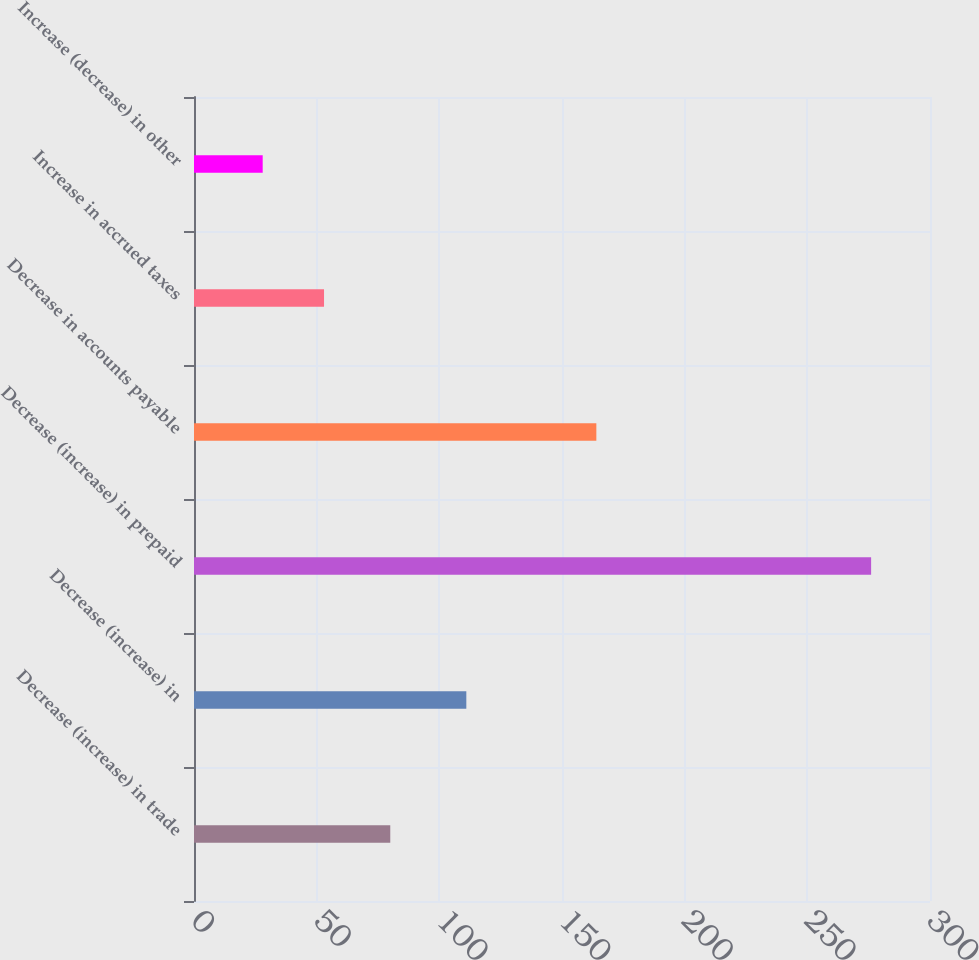Convert chart. <chart><loc_0><loc_0><loc_500><loc_500><bar_chart><fcel>Decrease (increase) in trade<fcel>Decrease (increase) in<fcel>Decrease (increase) in prepaid<fcel>Decrease in accounts payable<fcel>Increase in accrued taxes<fcel>Increase (decrease) in other<nl><fcel>80<fcel>111<fcel>276<fcel>164<fcel>53<fcel>28<nl></chart> 